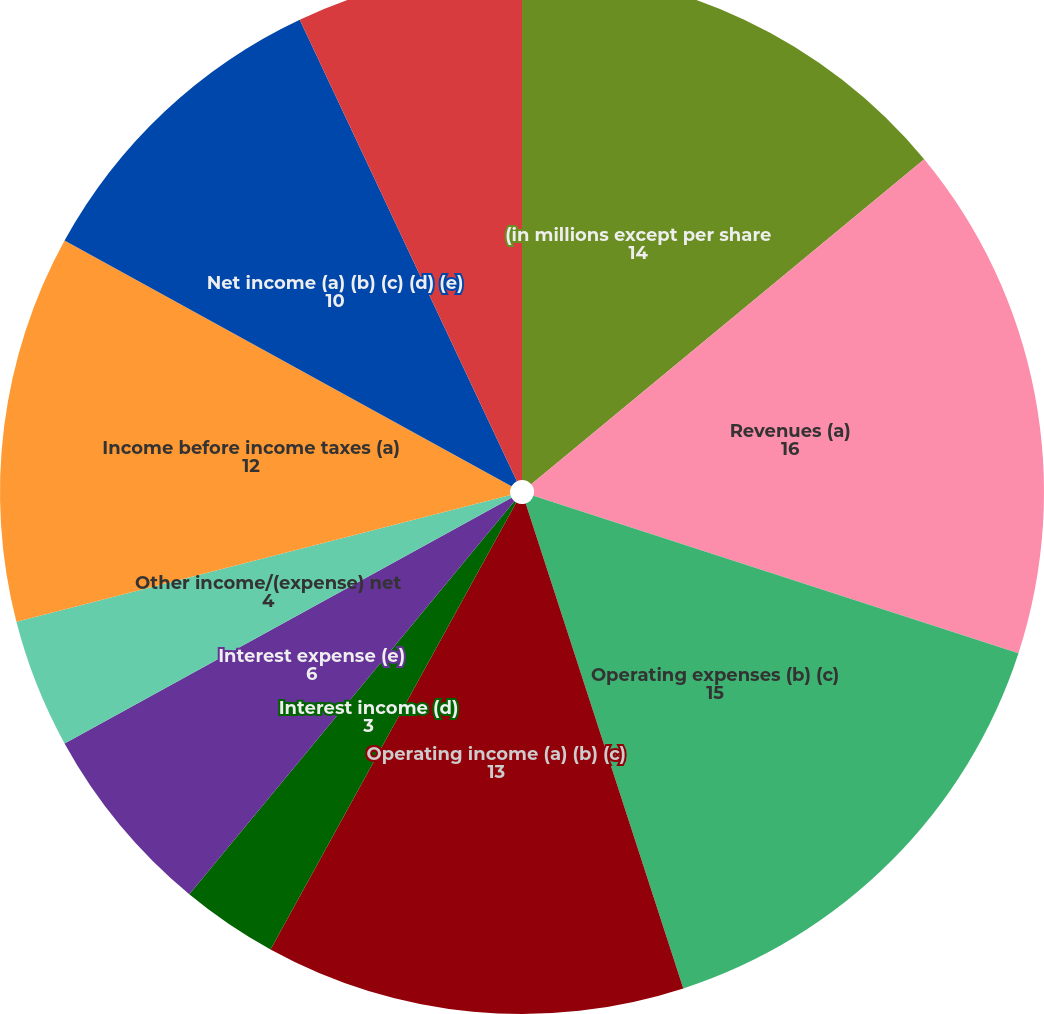<chart> <loc_0><loc_0><loc_500><loc_500><pie_chart><fcel>(in millions except per share<fcel>Revenues (a)<fcel>Operating expenses (b) (c)<fcel>Operating income (a) (b) (c)<fcel>Interest income (d)<fcel>Interest expense (e)<fcel>Other income/(expense) net<fcel>Income before income taxes (a)<fcel>Net income (a) (b) (c) (d) (e)<fcel>Depreciation and amortization<nl><fcel>14.0%<fcel>16.0%<fcel>15.0%<fcel>13.0%<fcel>3.0%<fcel>6.0%<fcel>4.0%<fcel>12.0%<fcel>10.0%<fcel>7.0%<nl></chart> 